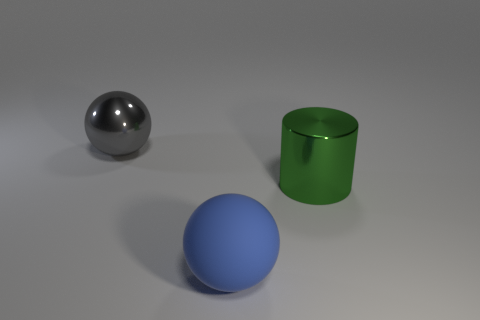What number of other things are there of the same material as the blue sphere There are no other objects of the same material as the blue sphere. The only other objects in the image are a green cylinder and a silver sphere, which appear to be made of different materials. 